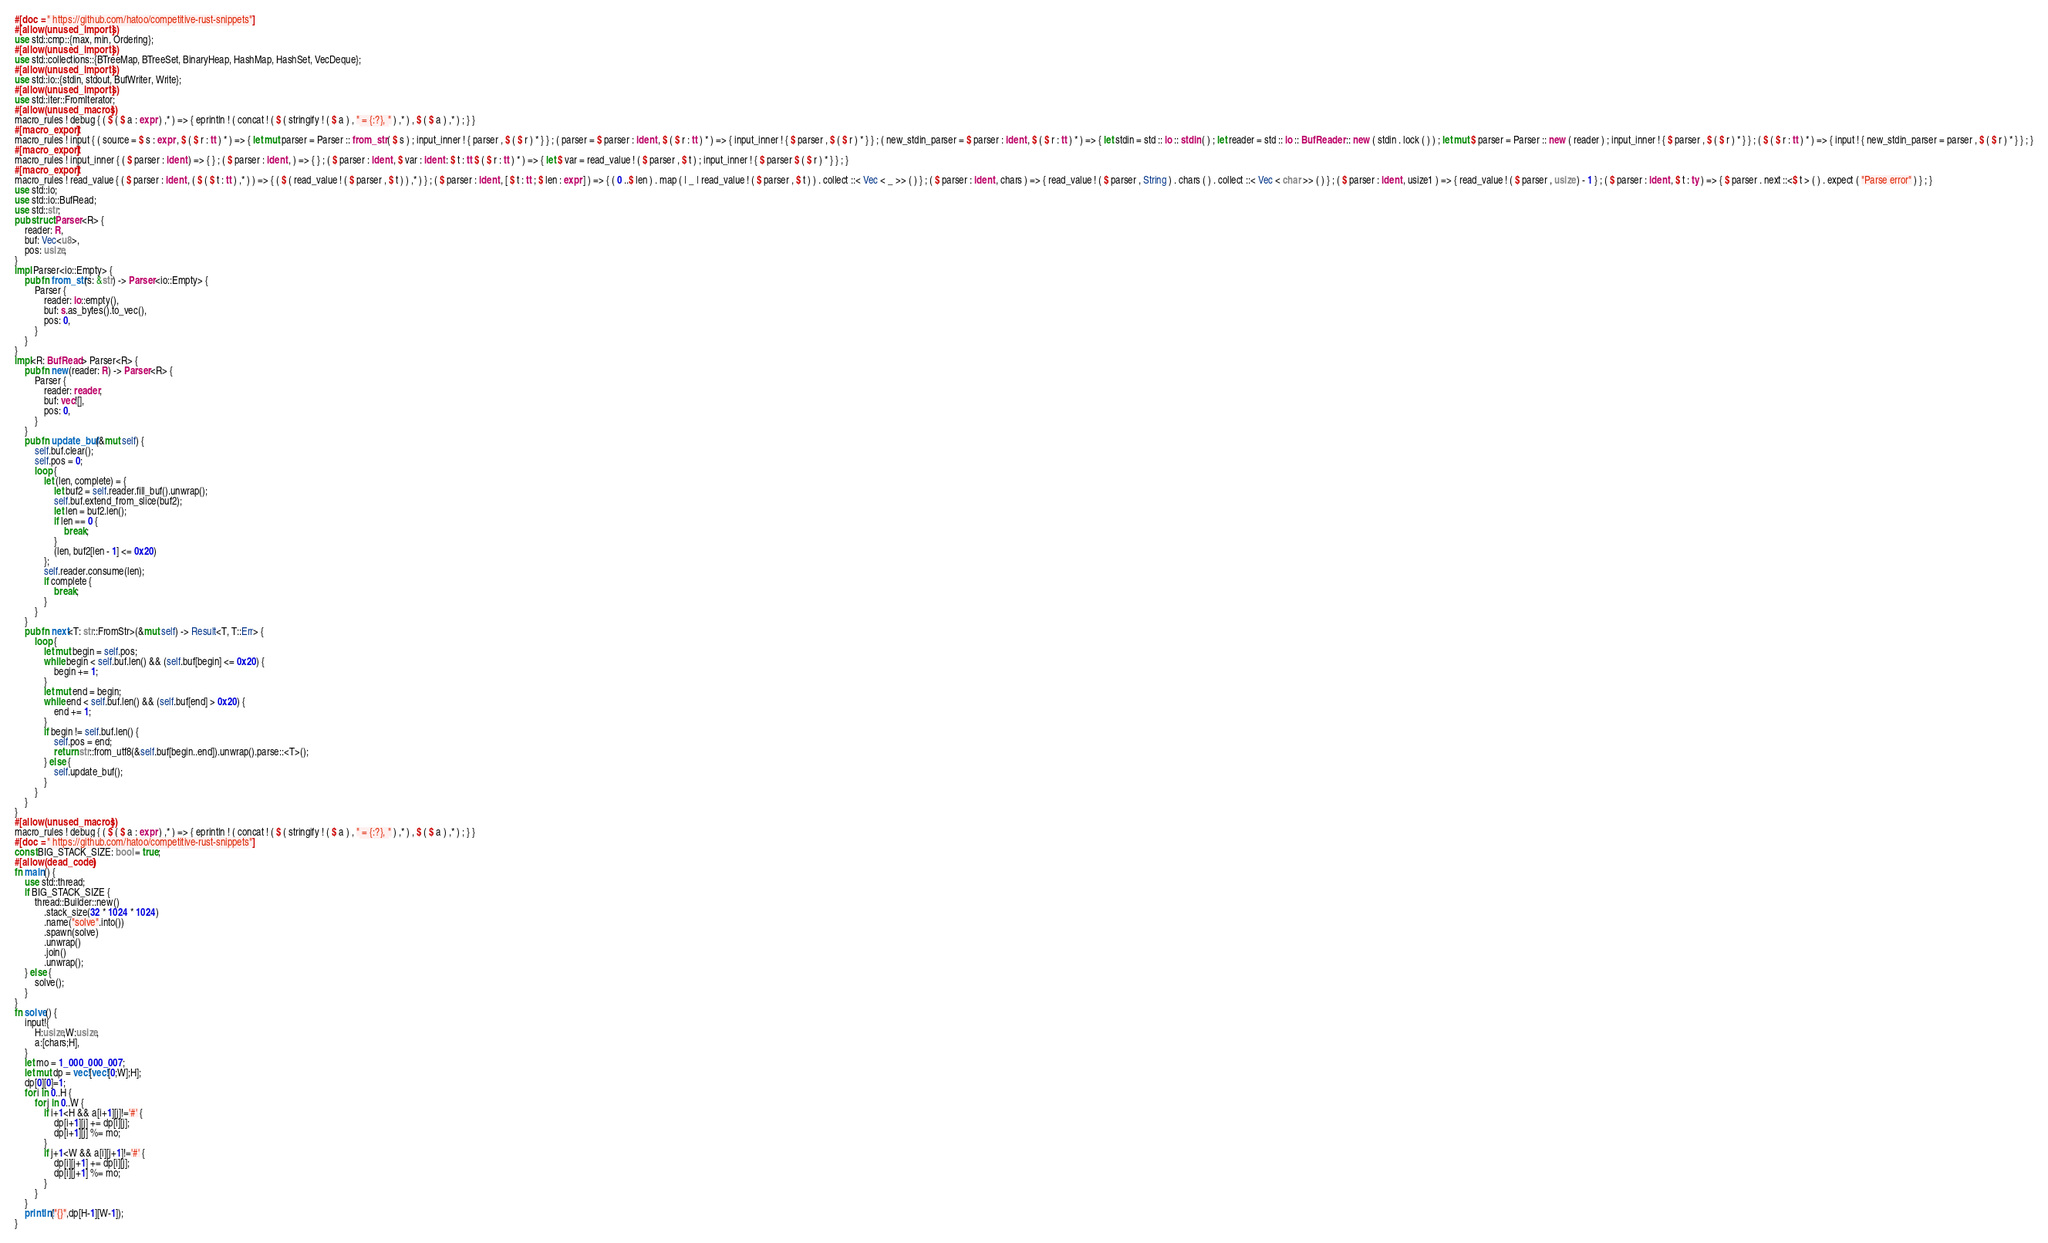<code> <loc_0><loc_0><loc_500><loc_500><_Rust_>#[doc = " https://github.com/hatoo/competitive-rust-snippets"]
#[allow(unused_imports)]
use std::cmp::{max, min, Ordering};
#[allow(unused_imports)]
use std::collections::{BTreeMap, BTreeSet, BinaryHeap, HashMap, HashSet, VecDeque};
#[allow(unused_imports)]
use std::io::{stdin, stdout, BufWriter, Write};
#[allow(unused_imports)]
use std::iter::FromIterator;
#[allow(unused_macros)]
macro_rules ! debug { ( $ ( $ a : expr ) ,* ) => { eprintln ! ( concat ! ( $ ( stringify ! ( $ a ) , " = {:?}, " ) ,* ) , $ ( $ a ) ,* ) ; } }
#[macro_export]
macro_rules ! input { ( source = $ s : expr , $ ( $ r : tt ) * ) => { let mut parser = Parser :: from_str ( $ s ) ; input_inner ! { parser , $ ( $ r ) * } } ; ( parser = $ parser : ident , $ ( $ r : tt ) * ) => { input_inner ! { $ parser , $ ( $ r ) * } } ; ( new_stdin_parser = $ parser : ident , $ ( $ r : tt ) * ) => { let stdin = std :: io :: stdin ( ) ; let reader = std :: io :: BufReader :: new ( stdin . lock ( ) ) ; let mut $ parser = Parser :: new ( reader ) ; input_inner ! { $ parser , $ ( $ r ) * } } ; ( $ ( $ r : tt ) * ) => { input ! { new_stdin_parser = parser , $ ( $ r ) * } } ; }
#[macro_export]
macro_rules ! input_inner { ( $ parser : ident ) => { } ; ( $ parser : ident , ) => { } ; ( $ parser : ident , $ var : ident : $ t : tt $ ( $ r : tt ) * ) => { let $ var = read_value ! ( $ parser , $ t ) ; input_inner ! { $ parser $ ( $ r ) * } } ; }
#[macro_export]
macro_rules ! read_value { ( $ parser : ident , ( $ ( $ t : tt ) ,* ) ) => { ( $ ( read_value ! ( $ parser , $ t ) ) ,* ) } ; ( $ parser : ident , [ $ t : tt ; $ len : expr ] ) => { ( 0 ..$ len ) . map ( | _ | read_value ! ( $ parser , $ t ) ) . collect ::< Vec < _ >> ( ) } ; ( $ parser : ident , chars ) => { read_value ! ( $ parser , String ) . chars ( ) . collect ::< Vec < char >> ( ) } ; ( $ parser : ident , usize1 ) => { read_value ! ( $ parser , usize ) - 1 } ; ( $ parser : ident , $ t : ty ) => { $ parser . next ::<$ t > ( ) . expect ( "Parse error" ) } ; }
use std::io;
use std::io::BufRead;
use std::str;
pub struct Parser<R> {
    reader: R,
    buf: Vec<u8>,
    pos: usize,
}
impl Parser<io::Empty> {
    pub fn from_str(s: &str) -> Parser<io::Empty> {
        Parser {
            reader: io::empty(),
            buf: s.as_bytes().to_vec(),
            pos: 0,
        }
    }
}
impl<R: BufRead> Parser<R> {
    pub fn new(reader: R) -> Parser<R> {
        Parser {
            reader: reader,
            buf: vec![],
            pos: 0,
        }
    }
    pub fn update_buf(&mut self) {
        self.buf.clear();
        self.pos = 0;
        loop {
            let (len, complete) = {
                let buf2 = self.reader.fill_buf().unwrap();
                self.buf.extend_from_slice(buf2);
                let len = buf2.len();
                if len == 0 {
                    break;
                }
                (len, buf2[len - 1] <= 0x20)
            };
            self.reader.consume(len);
            if complete {
                break;
            }
        }
    }
    pub fn next<T: str::FromStr>(&mut self) -> Result<T, T::Err> {
        loop {
            let mut begin = self.pos;
            while begin < self.buf.len() && (self.buf[begin] <= 0x20) {
                begin += 1;
            }
            let mut end = begin;
            while end < self.buf.len() && (self.buf[end] > 0x20) {
                end += 1;
            }
            if begin != self.buf.len() {
                self.pos = end;
                return str::from_utf8(&self.buf[begin..end]).unwrap().parse::<T>();
            } else {
                self.update_buf();
            }
        }
    }
}
#[allow(unused_macros)]
macro_rules ! debug { ( $ ( $ a : expr ) ,* ) => { eprintln ! ( concat ! ( $ ( stringify ! ( $ a ) , " = {:?}, " ) ,* ) , $ ( $ a ) ,* ) ; } }
#[doc = " https://github.com/hatoo/competitive-rust-snippets"]
const BIG_STACK_SIZE: bool = true;
#[allow(dead_code)]
fn main() {
    use std::thread;
    if BIG_STACK_SIZE {
        thread::Builder::new()
            .stack_size(32 * 1024 * 1024)
            .name("solve".into())
            .spawn(solve)
            .unwrap()
            .join()
            .unwrap();
    } else {
        solve();
    }
}
fn solve() {
    input!{
        H:usize,W:usize,
        a:[chars;H],
    }
    let mo = 1_000_000_007;
    let mut dp = vec![vec![0;W];H];
    dp[0][0]=1;
    for i in 0..H {
        for j in 0..W {
            if i+1<H && a[i+1][j]!='#' {
                dp[i+1][j] += dp[i][j];
                dp[i+1][j] %= mo;
            }
            if j+1<W && a[i][j+1]!='#' {
                dp[i][j+1] += dp[i][j];
                dp[i][j+1] %= mo;
            }
        }
    }
    println!("{}",dp[H-1][W-1]);
}</code> 